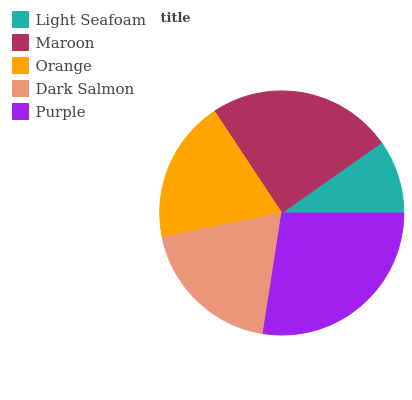Is Light Seafoam the minimum?
Answer yes or no. Yes. Is Purple the maximum?
Answer yes or no. Yes. Is Maroon the minimum?
Answer yes or no. No. Is Maroon the maximum?
Answer yes or no. No. Is Maroon greater than Light Seafoam?
Answer yes or no. Yes. Is Light Seafoam less than Maroon?
Answer yes or no. Yes. Is Light Seafoam greater than Maroon?
Answer yes or no. No. Is Maroon less than Light Seafoam?
Answer yes or no. No. Is Dark Salmon the high median?
Answer yes or no. Yes. Is Dark Salmon the low median?
Answer yes or no. Yes. Is Maroon the high median?
Answer yes or no. No. Is Maroon the low median?
Answer yes or no. No. 